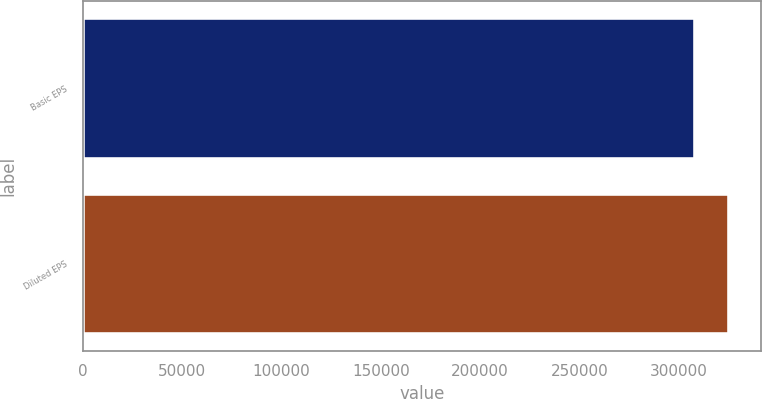Convert chart to OTSL. <chart><loc_0><loc_0><loc_500><loc_500><bar_chart><fcel>Basic EPS<fcel>Diluted EPS<nl><fcel>307984<fcel>325251<nl></chart> 